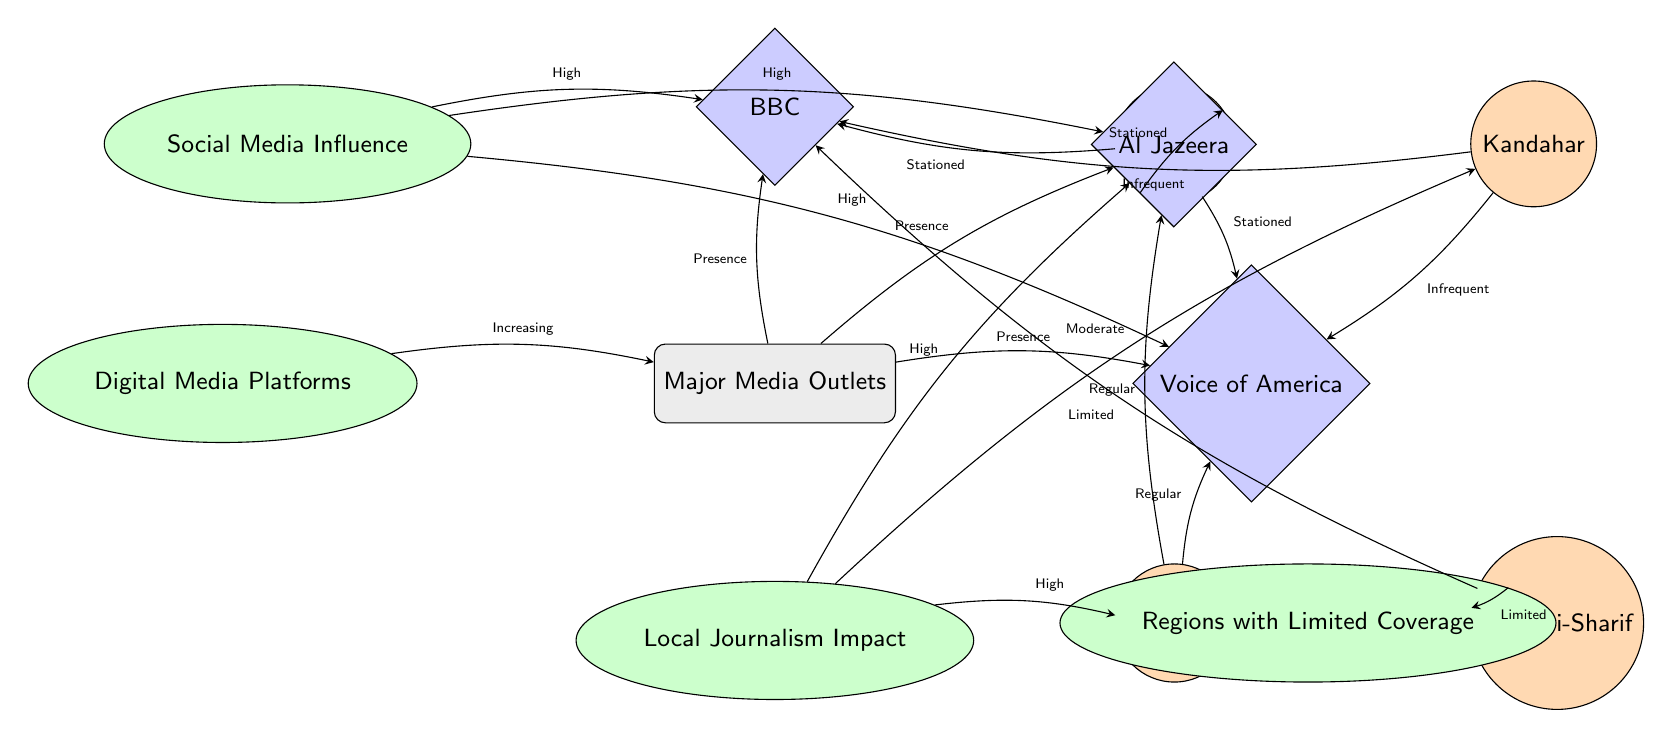What are the major media outlets represented in this diagram? The major media outlets are indicated as nodes directly connected to the "Major Media Outlets" node. They are BBC, Al Jazeera, and Voice of America.
Answer: BBC, Al Jazeera, Voice of America Which city is indicated as having 'Regular' coverage by Al Jazeera? The diagram shows an edge labeled 'Regular' connecting the city "Herat" to Al Jazeera, indicating the frequency of coverage.
Answer: Herat How many cities in the diagram are connected to the BBC? By reviewing the connections, we see that Kabul, Kandahar, and Mazar-i-Sharif are connected to the BBC. Counting these cities, we find three connections.
Answer: 3 What type of influence is high for the BBC according to the diagram? The edge leading from the "Social Media Influence" concept to the BBC node is labeled 'High', indicating the level of social media influence for this outlet.
Answer: High Which city has limited coverage of the BBC? The diagram specifies a direct edge from the "Regions with Limited Coverage" node connecting to Mazar-i-Sharif, indicating limited coverage of the BBC in this city.
Answer: Mazar-i-Sharif What term describes the relationship between digital media platforms and major media outlets? The diagram indicates a direct edge from the "Digital Media Platforms" concept to "Major Media Outlets" labeled 'Increasing', which reflects the influence of digital platforms on traditional media presence.
Answer: Increasing Which media outlet has a frequent presence in both Kabul and Herat? The diagram shows edges labeled 'Stationed' from Kabul to BBC, Al Jazeera, and Voice of America, and 'Regular' from Herat to Al Jazeera and Voice of America, where the common outlet is Voice of America.
Answer: Voice of America 